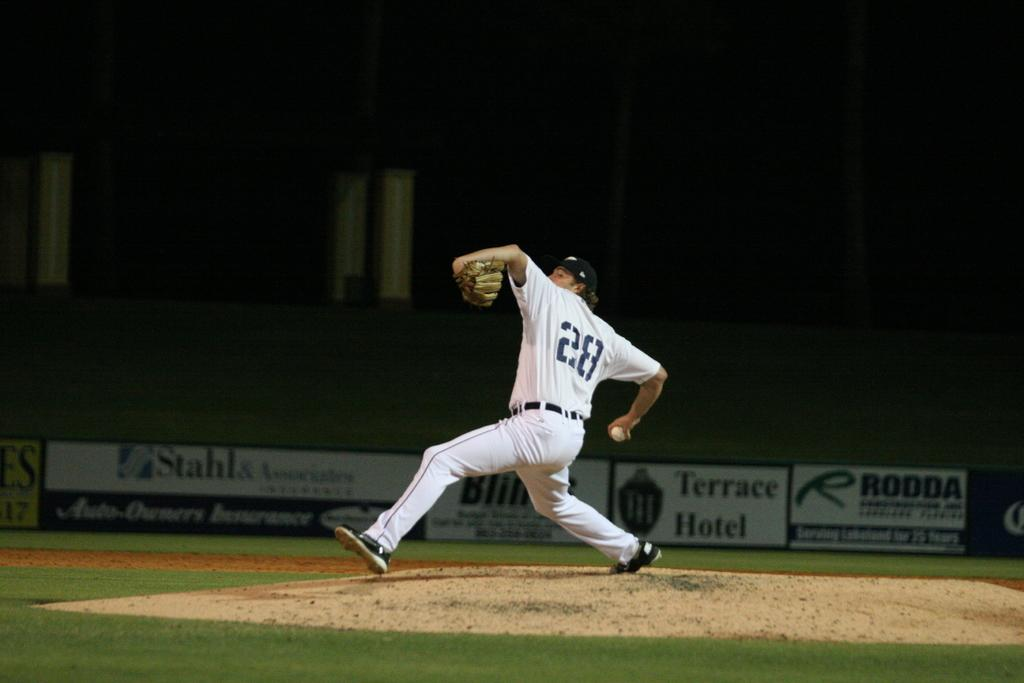<image>
Summarize the visual content of the image. Baseball player wearing number 28 throwing a baseball. 